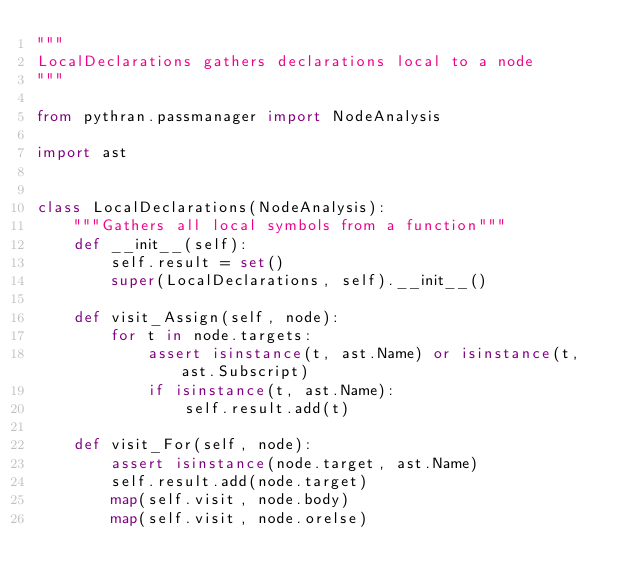Convert code to text. <code><loc_0><loc_0><loc_500><loc_500><_Python_>"""
LocalDeclarations gathers declarations local to a node
"""

from pythran.passmanager import NodeAnalysis

import ast


class LocalDeclarations(NodeAnalysis):
    """Gathers all local symbols from a function"""
    def __init__(self):
        self.result = set()
        super(LocalDeclarations, self).__init__()

    def visit_Assign(self, node):
        for t in node.targets:
            assert isinstance(t, ast.Name) or isinstance(t, ast.Subscript)
            if isinstance(t, ast.Name):
                self.result.add(t)

    def visit_For(self, node):
        assert isinstance(node.target, ast.Name)
        self.result.add(node.target)
        map(self.visit, node.body)
        map(self.visit, node.orelse)
</code> 